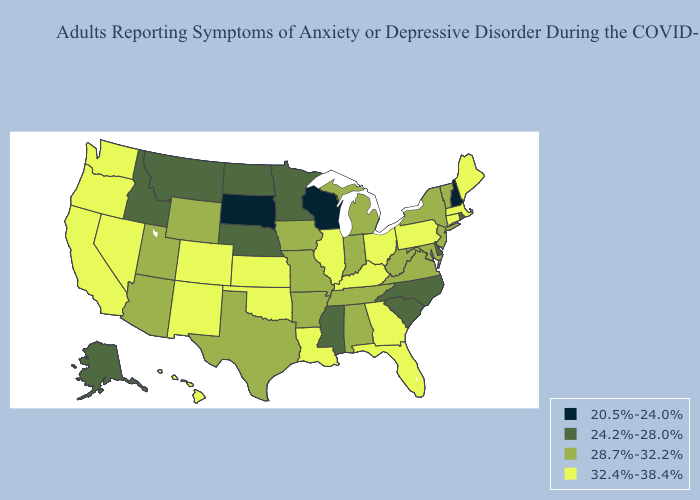Among the states that border West Virginia , does Pennsylvania have the highest value?
Be succinct. Yes. What is the lowest value in the Northeast?
Answer briefly. 20.5%-24.0%. Does Indiana have a lower value than Missouri?
Give a very brief answer. No. Name the states that have a value in the range 24.2%-28.0%?
Give a very brief answer. Alaska, Delaware, Idaho, Minnesota, Mississippi, Montana, Nebraska, North Carolina, North Dakota, Rhode Island, South Carolina. Does the first symbol in the legend represent the smallest category?
Answer briefly. Yes. Among the states that border Maryland , does Delaware have the lowest value?
Give a very brief answer. Yes. What is the value of Utah?
Short answer required. 28.7%-32.2%. What is the highest value in the West ?
Keep it brief. 32.4%-38.4%. Name the states that have a value in the range 20.5%-24.0%?
Be succinct. New Hampshire, South Dakota, Wisconsin. What is the lowest value in the USA?
Answer briefly. 20.5%-24.0%. What is the highest value in states that border West Virginia?
Answer briefly. 32.4%-38.4%. What is the lowest value in the USA?
Keep it brief. 20.5%-24.0%. Name the states that have a value in the range 20.5%-24.0%?
Be succinct. New Hampshire, South Dakota, Wisconsin. Name the states that have a value in the range 20.5%-24.0%?
Short answer required. New Hampshire, South Dakota, Wisconsin. Among the states that border Idaho , which have the highest value?
Concise answer only. Nevada, Oregon, Washington. 